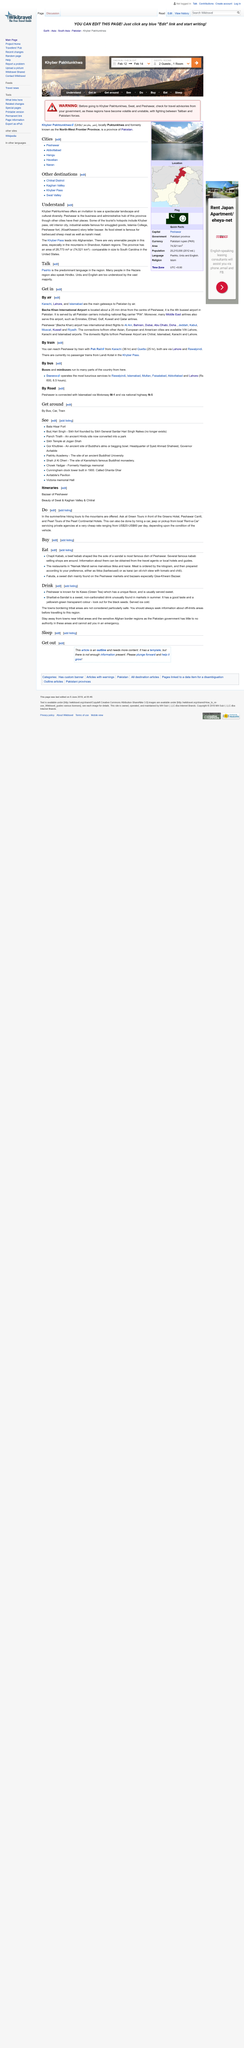List a handful of essential elements in this visual. Islamia College in Peshawar is the tourist hotspot according to Understand. The Chapli Kebab is the most renowned dish of Peshawar. In Peshawar, two popular beverages that can be found are Kawa and Sharbat-e-Sandal. The state of South Carolina has the same area size as Khyber Pakhtunkhwa. It is not recommended to visit towns bordering tribal areas. 